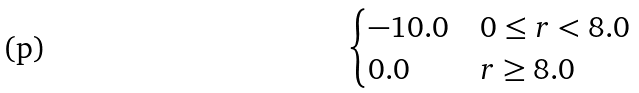<formula> <loc_0><loc_0><loc_500><loc_500>\begin{cases} - 1 0 . 0 & 0 \leq r < 8 . 0 \\ 0 . 0 & r \geq 8 . 0 \end{cases}</formula> 